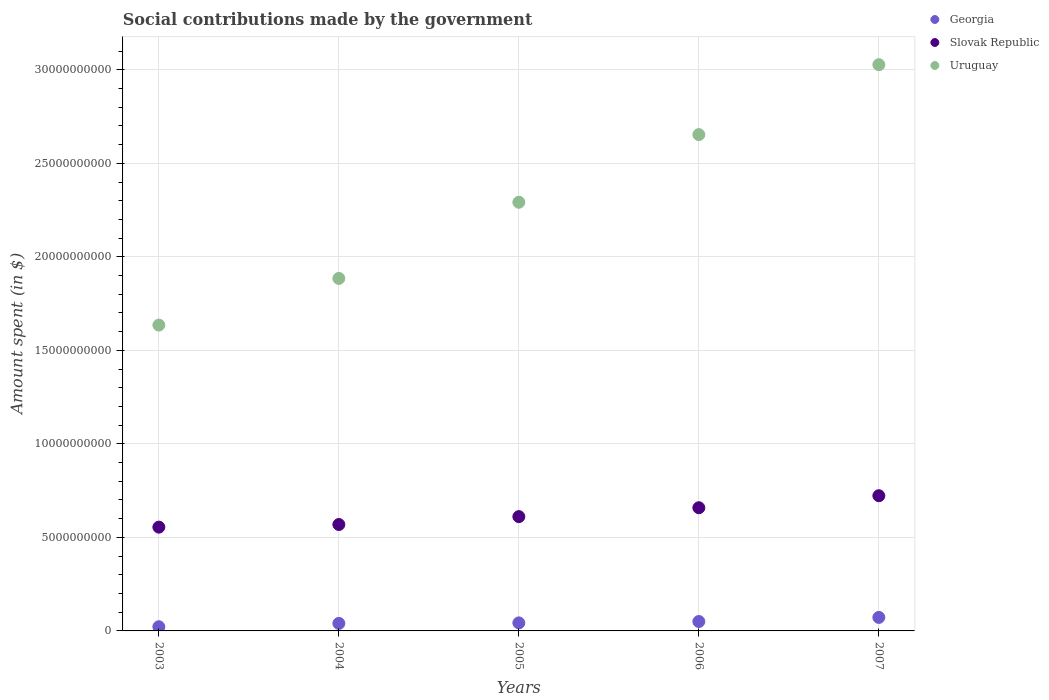How many different coloured dotlines are there?
Offer a terse response. 3. Is the number of dotlines equal to the number of legend labels?
Offer a very short reply. Yes. What is the amount spent on social contributions in Georgia in 2007?
Provide a short and direct response. 7.22e+08. Across all years, what is the maximum amount spent on social contributions in Slovak Republic?
Ensure brevity in your answer.  7.23e+09. Across all years, what is the minimum amount spent on social contributions in Uruguay?
Make the answer very short. 1.64e+1. In which year was the amount spent on social contributions in Georgia maximum?
Make the answer very short. 2007. In which year was the amount spent on social contributions in Slovak Republic minimum?
Your answer should be very brief. 2003. What is the total amount spent on social contributions in Georgia in the graph?
Provide a succinct answer. 2.28e+09. What is the difference between the amount spent on social contributions in Georgia in 2006 and that in 2007?
Offer a terse response. -2.19e+08. What is the difference between the amount spent on social contributions in Georgia in 2004 and the amount spent on social contributions in Slovak Republic in 2005?
Your response must be concise. -5.71e+09. What is the average amount spent on social contributions in Slovak Republic per year?
Your response must be concise. 6.23e+09. In the year 2003, what is the difference between the amount spent on social contributions in Georgia and amount spent on social contributions in Slovak Republic?
Your response must be concise. -5.33e+09. In how many years, is the amount spent on social contributions in Georgia greater than 4000000000 $?
Keep it short and to the point. 0. What is the ratio of the amount spent on social contributions in Slovak Republic in 2003 to that in 2005?
Your response must be concise. 0.91. What is the difference between the highest and the second highest amount spent on social contributions in Uruguay?
Ensure brevity in your answer.  3.74e+09. What is the difference between the highest and the lowest amount spent on social contributions in Slovak Republic?
Keep it short and to the point. 1.68e+09. In how many years, is the amount spent on social contributions in Slovak Republic greater than the average amount spent on social contributions in Slovak Republic taken over all years?
Give a very brief answer. 2. Does the amount spent on social contributions in Uruguay monotonically increase over the years?
Ensure brevity in your answer.  Yes. Is the amount spent on social contributions in Slovak Republic strictly less than the amount spent on social contributions in Georgia over the years?
Ensure brevity in your answer.  No. What is the difference between two consecutive major ticks on the Y-axis?
Offer a very short reply. 5.00e+09. Does the graph contain any zero values?
Your response must be concise. No. Does the graph contain grids?
Provide a succinct answer. Yes. Where does the legend appear in the graph?
Give a very brief answer. Top right. How are the legend labels stacked?
Offer a terse response. Vertical. What is the title of the graph?
Offer a terse response. Social contributions made by the government. What is the label or title of the X-axis?
Offer a terse response. Years. What is the label or title of the Y-axis?
Provide a succinct answer. Amount spent (in $). What is the Amount spent (in $) in Georgia in 2003?
Your answer should be compact. 2.23e+08. What is the Amount spent (in $) in Slovak Republic in 2003?
Offer a terse response. 5.55e+09. What is the Amount spent (in $) of Uruguay in 2003?
Ensure brevity in your answer.  1.64e+1. What is the Amount spent (in $) of Georgia in 2004?
Offer a very short reply. 4.02e+08. What is the Amount spent (in $) of Slovak Republic in 2004?
Give a very brief answer. 5.69e+09. What is the Amount spent (in $) of Uruguay in 2004?
Offer a terse response. 1.88e+1. What is the Amount spent (in $) in Georgia in 2005?
Make the answer very short. 4.29e+08. What is the Amount spent (in $) in Slovak Republic in 2005?
Offer a terse response. 6.11e+09. What is the Amount spent (in $) of Uruguay in 2005?
Provide a succinct answer. 2.29e+1. What is the Amount spent (in $) in Georgia in 2006?
Offer a very short reply. 5.03e+08. What is the Amount spent (in $) in Slovak Republic in 2006?
Keep it short and to the point. 6.59e+09. What is the Amount spent (in $) in Uruguay in 2006?
Make the answer very short. 2.65e+1. What is the Amount spent (in $) of Georgia in 2007?
Keep it short and to the point. 7.22e+08. What is the Amount spent (in $) of Slovak Republic in 2007?
Your response must be concise. 7.23e+09. What is the Amount spent (in $) of Uruguay in 2007?
Provide a succinct answer. 3.03e+1. Across all years, what is the maximum Amount spent (in $) of Georgia?
Provide a succinct answer. 7.22e+08. Across all years, what is the maximum Amount spent (in $) of Slovak Republic?
Ensure brevity in your answer.  7.23e+09. Across all years, what is the maximum Amount spent (in $) in Uruguay?
Your response must be concise. 3.03e+1. Across all years, what is the minimum Amount spent (in $) in Georgia?
Provide a short and direct response. 2.23e+08. Across all years, what is the minimum Amount spent (in $) in Slovak Republic?
Your response must be concise. 5.55e+09. Across all years, what is the minimum Amount spent (in $) in Uruguay?
Keep it short and to the point. 1.64e+1. What is the total Amount spent (in $) in Georgia in the graph?
Offer a terse response. 2.28e+09. What is the total Amount spent (in $) of Slovak Republic in the graph?
Your answer should be very brief. 3.12e+1. What is the total Amount spent (in $) in Uruguay in the graph?
Provide a short and direct response. 1.15e+11. What is the difference between the Amount spent (in $) of Georgia in 2003 and that in 2004?
Keep it short and to the point. -1.80e+08. What is the difference between the Amount spent (in $) of Slovak Republic in 2003 and that in 2004?
Offer a terse response. -1.40e+08. What is the difference between the Amount spent (in $) of Uruguay in 2003 and that in 2004?
Keep it short and to the point. -2.50e+09. What is the difference between the Amount spent (in $) in Georgia in 2003 and that in 2005?
Your answer should be compact. -2.06e+08. What is the difference between the Amount spent (in $) in Slovak Republic in 2003 and that in 2005?
Offer a very short reply. -5.62e+08. What is the difference between the Amount spent (in $) of Uruguay in 2003 and that in 2005?
Provide a succinct answer. -6.57e+09. What is the difference between the Amount spent (in $) of Georgia in 2003 and that in 2006?
Offer a terse response. -2.80e+08. What is the difference between the Amount spent (in $) of Slovak Republic in 2003 and that in 2006?
Offer a very short reply. -1.04e+09. What is the difference between the Amount spent (in $) in Uruguay in 2003 and that in 2006?
Give a very brief answer. -1.02e+1. What is the difference between the Amount spent (in $) of Georgia in 2003 and that in 2007?
Provide a short and direct response. -4.99e+08. What is the difference between the Amount spent (in $) in Slovak Republic in 2003 and that in 2007?
Keep it short and to the point. -1.68e+09. What is the difference between the Amount spent (in $) of Uruguay in 2003 and that in 2007?
Your answer should be compact. -1.39e+1. What is the difference between the Amount spent (in $) of Georgia in 2004 and that in 2005?
Provide a succinct answer. -2.66e+07. What is the difference between the Amount spent (in $) in Slovak Republic in 2004 and that in 2005?
Ensure brevity in your answer.  -4.22e+08. What is the difference between the Amount spent (in $) in Uruguay in 2004 and that in 2005?
Ensure brevity in your answer.  -4.07e+09. What is the difference between the Amount spent (in $) of Georgia in 2004 and that in 2006?
Your answer should be very brief. -1.01e+08. What is the difference between the Amount spent (in $) in Slovak Republic in 2004 and that in 2006?
Your answer should be compact. -8.98e+08. What is the difference between the Amount spent (in $) in Uruguay in 2004 and that in 2006?
Your answer should be compact. -7.69e+09. What is the difference between the Amount spent (in $) of Georgia in 2004 and that in 2007?
Ensure brevity in your answer.  -3.20e+08. What is the difference between the Amount spent (in $) of Slovak Republic in 2004 and that in 2007?
Offer a very short reply. -1.54e+09. What is the difference between the Amount spent (in $) in Uruguay in 2004 and that in 2007?
Keep it short and to the point. -1.14e+1. What is the difference between the Amount spent (in $) of Georgia in 2005 and that in 2006?
Offer a terse response. -7.40e+07. What is the difference between the Amount spent (in $) of Slovak Republic in 2005 and that in 2006?
Your answer should be compact. -4.75e+08. What is the difference between the Amount spent (in $) in Uruguay in 2005 and that in 2006?
Keep it short and to the point. -3.62e+09. What is the difference between the Amount spent (in $) in Georgia in 2005 and that in 2007?
Offer a very short reply. -2.93e+08. What is the difference between the Amount spent (in $) of Slovak Republic in 2005 and that in 2007?
Your response must be concise. -1.12e+09. What is the difference between the Amount spent (in $) in Uruguay in 2005 and that in 2007?
Offer a terse response. -7.36e+09. What is the difference between the Amount spent (in $) of Georgia in 2006 and that in 2007?
Your answer should be very brief. -2.19e+08. What is the difference between the Amount spent (in $) of Slovak Republic in 2006 and that in 2007?
Give a very brief answer. -6.41e+08. What is the difference between the Amount spent (in $) in Uruguay in 2006 and that in 2007?
Keep it short and to the point. -3.74e+09. What is the difference between the Amount spent (in $) in Georgia in 2003 and the Amount spent (in $) in Slovak Republic in 2004?
Offer a terse response. -5.47e+09. What is the difference between the Amount spent (in $) of Georgia in 2003 and the Amount spent (in $) of Uruguay in 2004?
Your answer should be compact. -1.86e+1. What is the difference between the Amount spent (in $) of Slovak Republic in 2003 and the Amount spent (in $) of Uruguay in 2004?
Provide a short and direct response. -1.33e+1. What is the difference between the Amount spent (in $) in Georgia in 2003 and the Amount spent (in $) in Slovak Republic in 2005?
Offer a very short reply. -5.89e+09. What is the difference between the Amount spent (in $) of Georgia in 2003 and the Amount spent (in $) of Uruguay in 2005?
Make the answer very short. -2.27e+1. What is the difference between the Amount spent (in $) in Slovak Republic in 2003 and the Amount spent (in $) in Uruguay in 2005?
Provide a short and direct response. -1.74e+1. What is the difference between the Amount spent (in $) in Georgia in 2003 and the Amount spent (in $) in Slovak Republic in 2006?
Offer a very short reply. -6.36e+09. What is the difference between the Amount spent (in $) in Georgia in 2003 and the Amount spent (in $) in Uruguay in 2006?
Your response must be concise. -2.63e+1. What is the difference between the Amount spent (in $) of Slovak Republic in 2003 and the Amount spent (in $) of Uruguay in 2006?
Make the answer very short. -2.10e+1. What is the difference between the Amount spent (in $) in Georgia in 2003 and the Amount spent (in $) in Slovak Republic in 2007?
Give a very brief answer. -7.01e+09. What is the difference between the Amount spent (in $) of Georgia in 2003 and the Amount spent (in $) of Uruguay in 2007?
Give a very brief answer. -3.01e+1. What is the difference between the Amount spent (in $) in Slovak Republic in 2003 and the Amount spent (in $) in Uruguay in 2007?
Make the answer very short. -2.47e+1. What is the difference between the Amount spent (in $) in Georgia in 2004 and the Amount spent (in $) in Slovak Republic in 2005?
Ensure brevity in your answer.  -5.71e+09. What is the difference between the Amount spent (in $) of Georgia in 2004 and the Amount spent (in $) of Uruguay in 2005?
Give a very brief answer. -2.25e+1. What is the difference between the Amount spent (in $) in Slovak Republic in 2004 and the Amount spent (in $) in Uruguay in 2005?
Provide a succinct answer. -1.72e+1. What is the difference between the Amount spent (in $) in Georgia in 2004 and the Amount spent (in $) in Slovak Republic in 2006?
Your answer should be very brief. -6.18e+09. What is the difference between the Amount spent (in $) of Georgia in 2004 and the Amount spent (in $) of Uruguay in 2006?
Your response must be concise. -2.61e+1. What is the difference between the Amount spent (in $) in Slovak Republic in 2004 and the Amount spent (in $) in Uruguay in 2006?
Provide a succinct answer. -2.08e+1. What is the difference between the Amount spent (in $) in Georgia in 2004 and the Amount spent (in $) in Slovak Republic in 2007?
Provide a short and direct response. -6.83e+09. What is the difference between the Amount spent (in $) of Georgia in 2004 and the Amount spent (in $) of Uruguay in 2007?
Keep it short and to the point. -2.99e+1. What is the difference between the Amount spent (in $) in Slovak Republic in 2004 and the Amount spent (in $) in Uruguay in 2007?
Offer a terse response. -2.46e+1. What is the difference between the Amount spent (in $) in Georgia in 2005 and the Amount spent (in $) in Slovak Republic in 2006?
Offer a terse response. -6.16e+09. What is the difference between the Amount spent (in $) of Georgia in 2005 and the Amount spent (in $) of Uruguay in 2006?
Give a very brief answer. -2.61e+1. What is the difference between the Amount spent (in $) of Slovak Republic in 2005 and the Amount spent (in $) of Uruguay in 2006?
Give a very brief answer. -2.04e+1. What is the difference between the Amount spent (in $) in Georgia in 2005 and the Amount spent (in $) in Slovak Republic in 2007?
Offer a very short reply. -6.80e+09. What is the difference between the Amount spent (in $) in Georgia in 2005 and the Amount spent (in $) in Uruguay in 2007?
Make the answer very short. -2.98e+1. What is the difference between the Amount spent (in $) of Slovak Republic in 2005 and the Amount spent (in $) of Uruguay in 2007?
Keep it short and to the point. -2.42e+1. What is the difference between the Amount spent (in $) in Georgia in 2006 and the Amount spent (in $) in Slovak Republic in 2007?
Ensure brevity in your answer.  -6.72e+09. What is the difference between the Amount spent (in $) in Georgia in 2006 and the Amount spent (in $) in Uruguay in 2007?
Your answer should be compact. -2.98e+1. What is the difference between the Amount spent (in $) of Slovak Republic in 2006 and the Amount spent (in $) of Uruguay in 2007?
Give a very brief answer. -2.37e+1. What is the average Amount spent (in $) in Georgia per year?
Your answer should be very brief. 4.56e+08. What is the average Amount spent (in $) of Slovak Republic per year?
Make the answer very short. 6.23e+09. What is the average Amount spent (in $) of Uruguay per year?
Keep it short and to the point. 2.30e+1. In the year 2003, what is the difference between the Amount spent (in $) in Georgia and Amount spent (in $) in Slovak Republic?
Provide a succinct answer. -5.33e+09. In the year 2003, what is the difference between the Amount spent (in $) of Georgia and Amount spent (in $) of Uruguay?
Provide a succinct answer. -1.61e+1. In the year 2003, what is the difference between the Amount spent (in $) in Slovak Republic and Amount spent (in $) in Uruguay?
Make the answer very short. -1.08e+1. In the year 2004, what is the difference between the Amount spent (in $) of Georgia and Amount spent (in $) of Slovak Republic?
Offer a very short reply. -5.29e+09. In the year 2004, what is the difference between the Amount spent (in $) in Georgia and Amount spent (in $) in Uruguay?
Your response must be concise. -1.84e+1. In the year 2004, what is the difference between the Amount spent (in $) of Slovak Republic and Amount spent (in $) of Uruguay?
Provide a short and direct response. -1.32e+1. In the year 2005, what is the difference between the Amount spent (in $) of Georgia and Amount spent (in $) of Slovak Republic?
Provide a succinct answer. -5.68e+09. In the year 2005, what is the difference between the Amount spent (in $) of Georgia and Amount spent (in $) of Uruguay?
Make the answer very short. -2.25e+1. In the year 2005, what is the difference between the Amount spent (in $) in Slovak Republic and Amount spent (in $) in Uruguay?
Provide a succinct answer. -1.68e+1. In the year 2006, what is the difference between the Amount spent (in $) of Georgia and Amount spent (in $) of Slovak Republic?
Make the answer very short. -6.08e+09. In the year 2006, what is the difference between the Amount spent (in $) in Georgia and Amount spent (in $) in Uruguay?
Offer a terse response. -2.60e+1. In the year 2006, what is the difference between the Amount spent (in $) in Slovak Republic and Amount spent (in $) in Uruguay?
Offer a terse response. -1.99e+1. In the year 2007, what is the difference between the Amount spent (in $) of Georgia and Amount spent (in $) of Slovak Republic?
Give a very brief answer. -6.51e+09. In the year 2007, what is the difference between the Amount spent (in $) in Georgia and Amount spent (in $) in Uruguay?
Offer a terse response. -2.96e+1. In the year 2007, what is the difference between the Amount spent (in $) of Slovak Republic and Amount spent (in $) of Uruguay?
Provide a succinct answer. -2.30e+1. What is the ratio of the Amount spent (in $) in Georgia in 2003 to that in 2004?
Offer a terse response. 0.55. What is the ratio of the Amount spent (in $) of Slovak Republic in 2003 to that in 2004?
Make the answer very short. 0.98. What is the ratio of the Amount spent (in $) in Uruguay in 2003 to that in 2004?
Provide a succinct answer. 0.87. What is the ratio of the Amount spent (in $) of Georgia in 2003 to that in 2005?
Provide a succinct answer. 0.52. What is the ratio of the Amount spent (in $) of Slovak Republic in 2003 to that in 2005?
Ensure brevity in your answer.  0.91. What is the ratio of the Amount spent (in $) of Uruguay in 2003 to that in 2005?
Keep it short and to the point. 0.71. What is the ratio of the Amount spent (in $) of Georgia in 2003 to that in 2006?
Give a very brief answer. 0.44. What is the ratio of the Amount spent (in $) of Slovak Republic in 2003 to that in 2006?
Ensure brevity in your answer.  0.84. What is the ratio of the Amount spent (in $) in Uruguay in 2003 to that in 2006?
Your answer should be very brief. 0.62. What is the ratio of the Amount spent (in $) in Georgia in 2003 to that in 2007?
Provide a short and direct response. 0.31. What is the ratio of the Amount spent (in $) of Slovak Republic in 2003 to that in 2007?
Your answer should be compact. 0.77. What is the ratio of the Amount spent (in $) of Uruguay in 2003 to that in 2007?
Give a very brief answer. 0.54. What is the ratio of the Amount spent (in $) in Georgia in 2004 to that in 2005?
Give a very brief answer. 0.94. What is the ratio of the Amount spent (in $) of Slovak Republic in 2004 to that in 2005?
Your answer should be compact. 0.93. What is the ratio of the Amount spent (in $) of Uruguay in 2004 to that in 2005?
Your answer should be very brief. 0.82. What is the ratio of the Amount spent (in $) in Georgia in 2004 to that in 2006?
Your response must be concise. 0.8. What is the ratio of the Amount spent (in $) in Slovak Republic in 2004 to that in 2006?
Give a very brief answer. 0.86. What is the ratio of the Amount spent (in $) of Uruguay in 2004 to that in 2006?
Your response must be concise. 0.71. What is the ratio of the Amount spent (in $) in Georgia in 2004 to that in 2007?
Make the answer very short. 0.56. What is the ratio of the Amount spent (in $) of Slovak Republic in 2004 to that in 2007?
Provide a succinct answer. 0.79. What is the ratio of the Amount spent (in $) of Uruguay in 2004 to that in 2007?
Offer a very short reply. 0.62. What is the ratio of the Amount spent (in $) of Georgia in 2005 to that in 2006?
Ensure brevity in your answer.  0.85. What is the ratio of the Amount spent (in $) in Slovak Republic in 2005 to that in 2006?
Provide a succinct answer. 0.93. What is the ratio of the Amount spent (in $) in Uruguay in 2005 to that in 2006?
Your answer should be compact. 0.86. What is the ratio of the Amount spent (in $) of Georgia in 2005 to that in 2007?
Your answer should be compact. 0.59. What is the ratio of the Amount spent (in $) of Slovak Republic in 2005 to that in 2007?
Your answer should be very brief. 0.85. What is the ratio of the Amount spent (in $) of Uruguay in 2005 to that in 2007?
Your answer should be very brief. 0.76. What is the ratio of the Amount spent (in $) of Georgia in 2006 to that in 2007?
Your answer should be very brief. 0.7. What is the ratio of the Amount spent (in $) in Slovak Republic in 2006 to that in 2007?
Provide a short and direct response. 0.91. What is the ratio of the Amount spent (in $) in Uruguay in 2006 to that in 2007?
Make the answer very short. 0.88. What is the difference between the highest and the second highest Amount spent (in $) in Georgia?
Give a very brief answer. 2.19e+08. What is the difference between the highest and the second highest Amount spent (in $) in Slovak Republic?
Offer a terse response. 6.41e+08. What is the difference between the highest and the second highest Amount spent (in $) in Uruguay?
Keep it short and to the point. 3.74e+09. What is the difference between the highest and the lowest Amount spent (in $) of Georgia?
Make the answer very short. 4.99e+08. What is the difference between the highest and the lowest Amount spent (in $) in Slovak Republic?
Offer a very short reply. 1.68e+09. What is the difference between the highest and the lowest Amount spent (in $) of Uruguay?
Make the answer very short. 1.39e+1. 